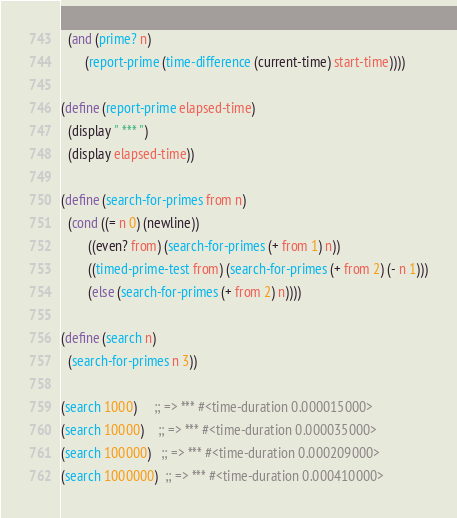Convert code to text. <code><loc_0><loc_0><loc_500><loc_500><_Scheme_>  (and (prime? n)
       (report-prime (time-difference (current-time) start-time))))

(define (report-prime elapsed-time)
  (display " *** ")
  (display elapsed-time))

(define (search-for-primes from n)
  (cond ((= n 0) (newline))
        ((even? from) (search-for-primes (+ from 1) n))
        ((timed-prime-test from) (search-for-primes (+ from 2) (- n 1)))
        (else (search-for-primes (+ from 2) n))))

(define (search n)
  (search-for-primes n 3))

(search 1000)     ;; => *** #<time-duration 0.000015000>
(search 10000)    ;; => *** #<time-duration 0.000035000>
(search 100000)   ;; => *** #<time-duration 0.000209000>
(search 1000000)  ;; => *** #<time-duration 0.000410000></code> 